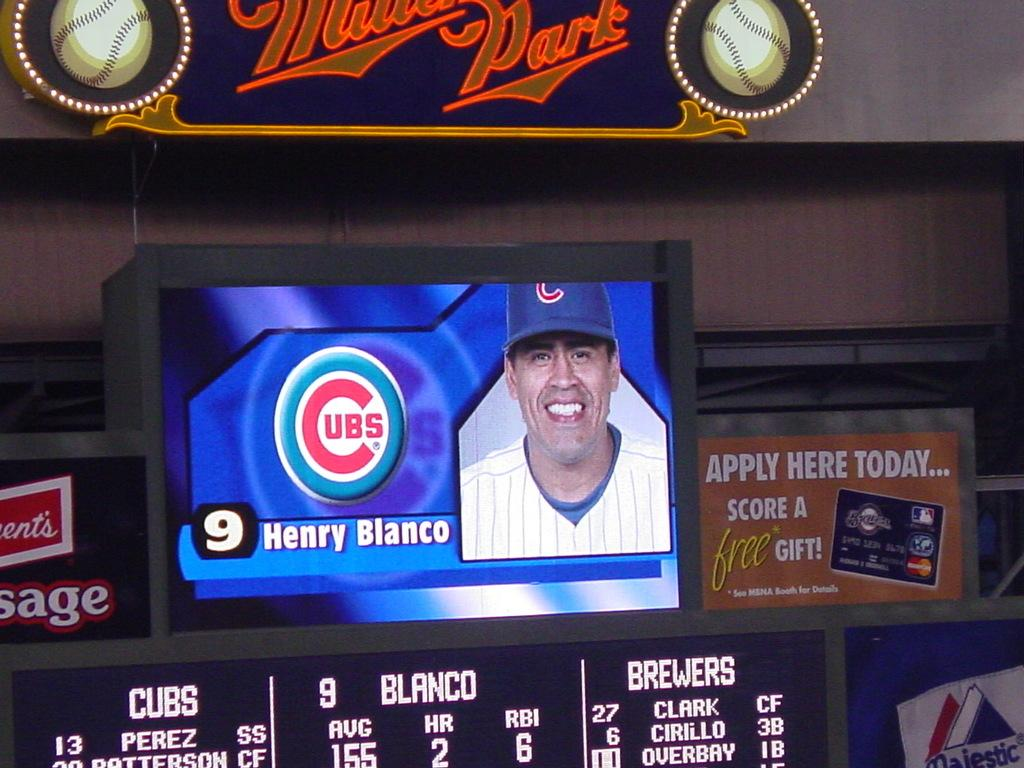Provide a one-sentence caption for the provided image. a screen showing a baseball player named Henry Blanco. 